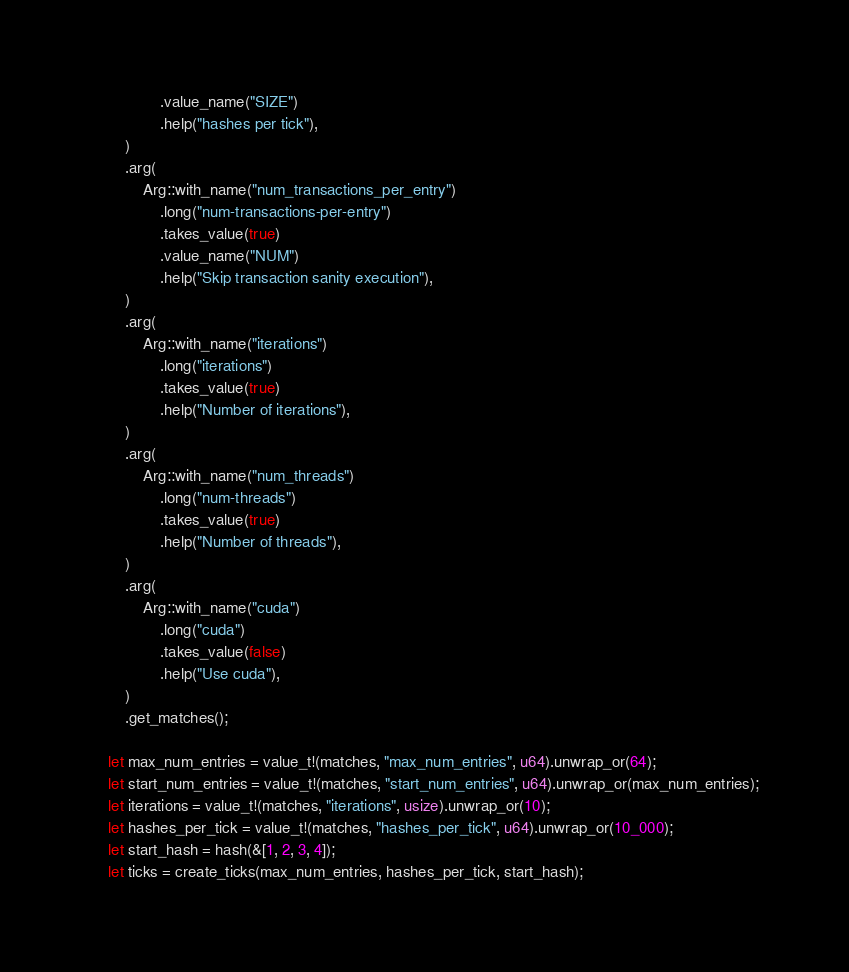<code> <loc_0><loc_0><loc_500><loc_500><_Rust_>                .value_name("SIZE")
                .help("hashes per tick"),
        )
        .arg(
            Arg::with_name("num_transactions_per_entry")
                .long("num-transactions-per-entry")
                .takes_value(true)
                .value_name("NUM")
                .help("Skip transaction sanity execution"),
        )
        .arg(
            Arg::with_name("iterations")
                .long("iterations")
                .takes_value(true)
                .help("Number of iterations"),
        )
        .arg(
            Arg::with_name("num_threads")
                .long("num-threads")
                .takes_value(true)
                .help("Number of threads"),
        )
        .arg(
            Arg::with_name("cuda")
                .long("cuda")
                .takes_value(false)
                .help("Use cuda"),
        )
        .get_matches();

    let max_num_entries = value_t!(matches, "max_num_entries", u64).unwrap_or(64);
    let start_num_entries = value_t!(matches, "start_num_entries", u64).unwrap_or(max_num_entries);
    let iterations = value_t!(matches, "iterations", usize).unwrap_or(10);
    let hashes_per_tick = value_t!(matches, "hashes_per_tick", u64).unwrap_or(10_000);
    let start_hash = hash(&[1, 2, 3, 4]);
    let ticks = create_ticks(max_num_entries, hashes_per_tick, start_hash);</code> 